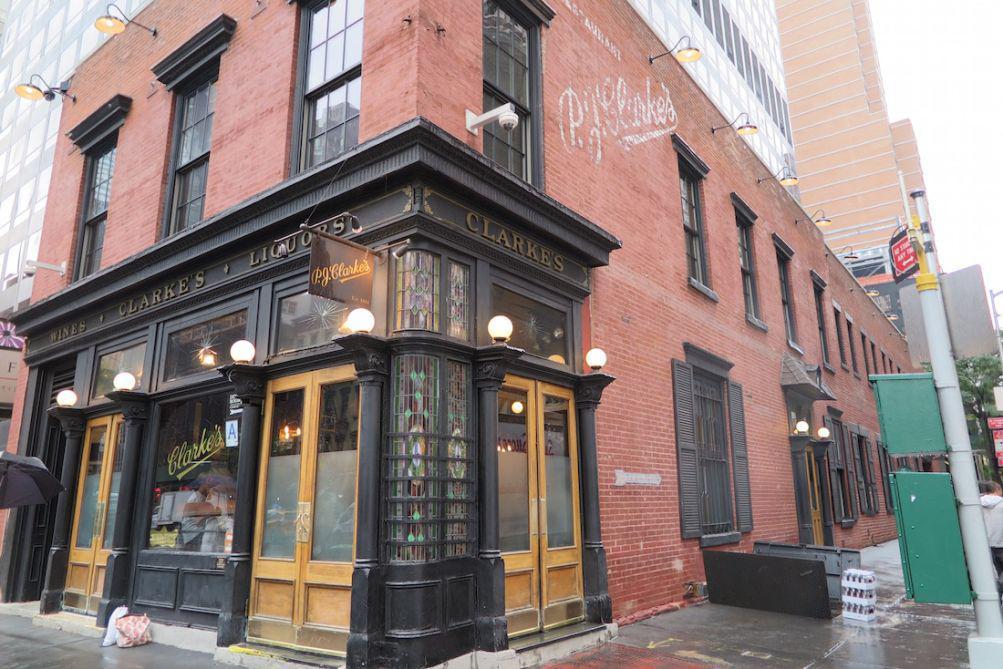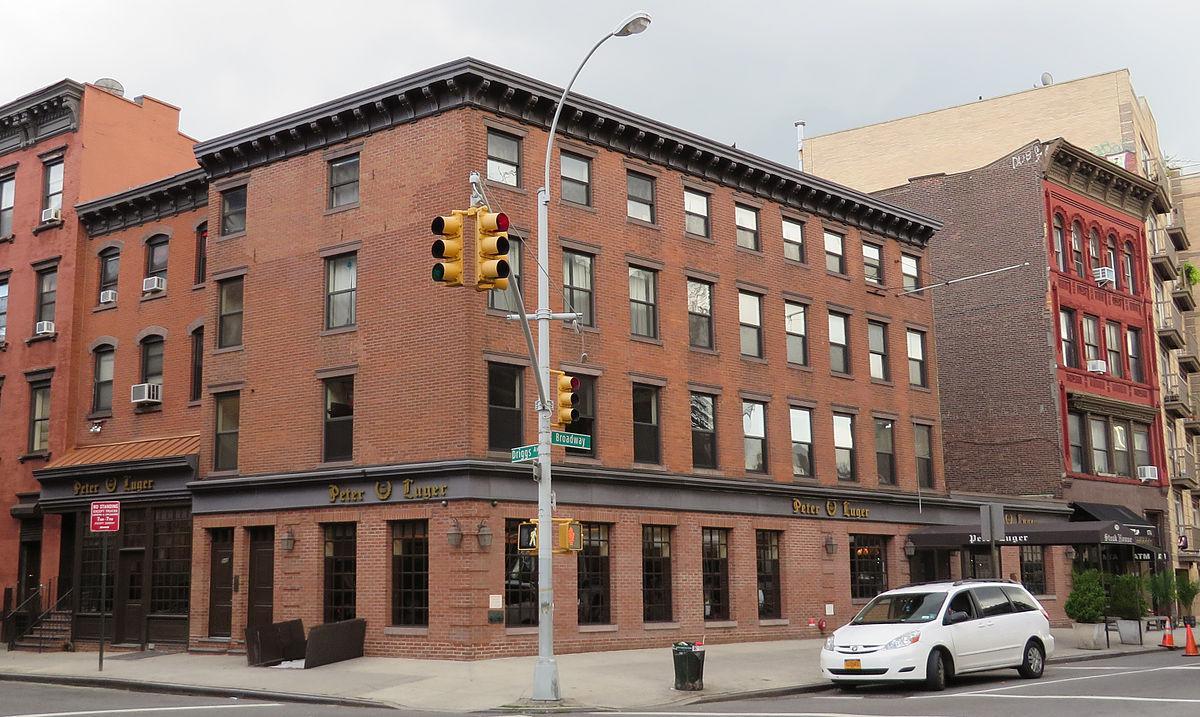The first image is the image on the left, the second image is the image on the right. Examine the images to the left and right. Is the description "There is a front awning in the left image." accurate? Answer yes or no. No. The first image is the image on the left, the second image is the image on the right. Evaluate the accuracy of this statement regarding the images: "The right image shows at least one person in front of a black roof that extends out from a red brick building.". Is it true? Answer yes or no. No. 